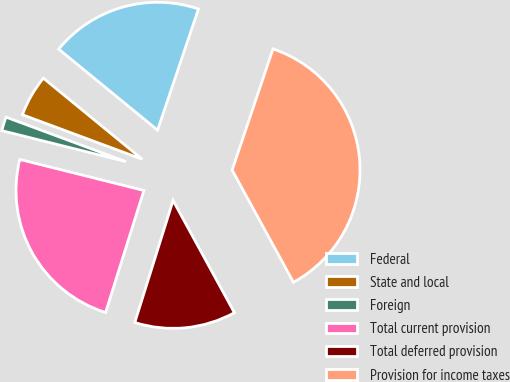Convert chart to OTSL. <chart><loc_0><loc_0><loc_500><loc_500><pie_chart><fcel>Federal<fcel>State and local<fcel>Foreign<fcel>Total current provision<fcel>Total deferred provision<fcel>Provision for income taxes<nl><fcel>19.25%<fcel>5.27%<fcel>1.76%<fcel>24.06%<fcel>12.8%<fcel>36.86%<nl></chart> 